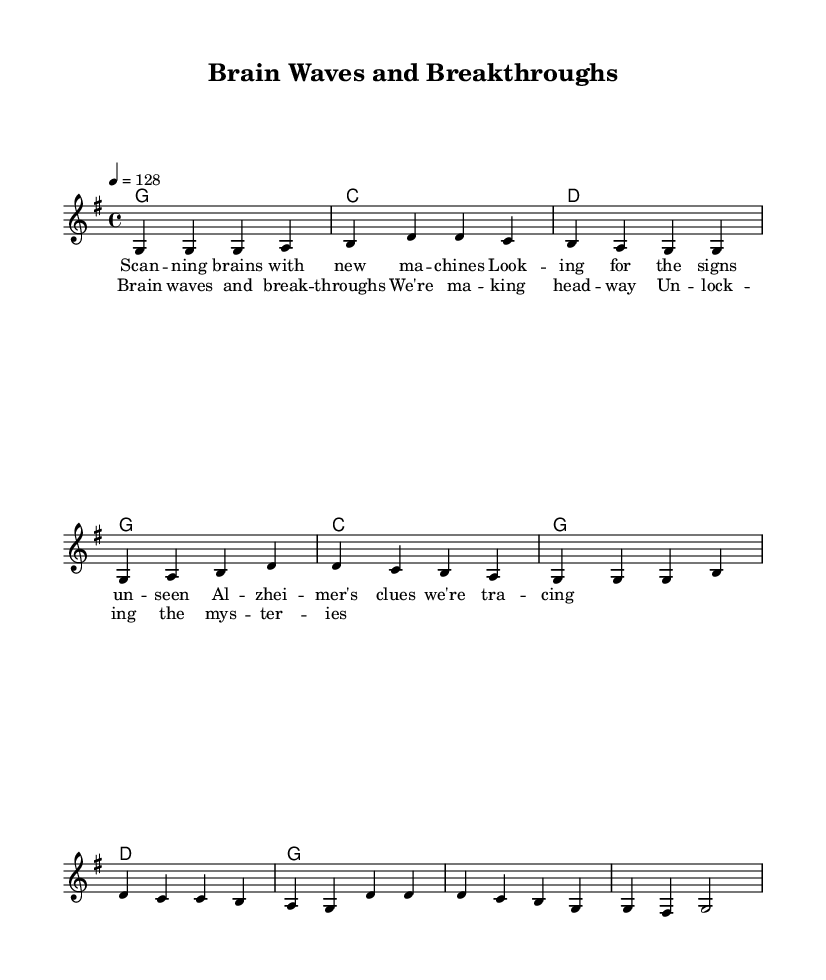What is the key signature of this music? The key signature is G major, which has one sharp (F#). This can be identified from the beginning of the piece, where the key is indicated in the global music settings.
Answer: G major What is the time signature of this music? The time signature is 4/4, which is indicated at the start of the score in the global settings. This means there are four beats in each measure.
Answer: 4/4 What is the tempo marking for this piece? The tempo marking is 128 beats per minute, as stated in the global settings. This indicates the speed at which the piece is meant to be played.
Answer: 128 How many measures are there in the verse? There are 5 measures in the verse, as counted from the melody section where the verse is notated. Each group of notes separated by vertical lines indicates a measure.
Answer: 5 What is the first note of the chorus? The first note of the chorus is G. This can be identified by analyzing the melody line where the chorus begins.
Answer: G How is the mood of the song conveyed through its structure? The mood can be perceived as upbeat due to the utilization of major chords, the fast tempo, and a lively melody. The combination of a catchy melody and the positive themes in the lyrics also contribute to this upbeat feeling characteristic of Country Rock.
Answer: Upbeat What thematic elements are reflected in the lyrics of this song? The lyrics focus on scientific themes, specifically brain imaging and discoveries related to Alzheimer's disease. This intertwines both medical knowledge and an uplifting, hopeful outlook regarding breakthroughs in science, which is a common theme in Country Rock songs.
Answer: Scientific breakthroughs 